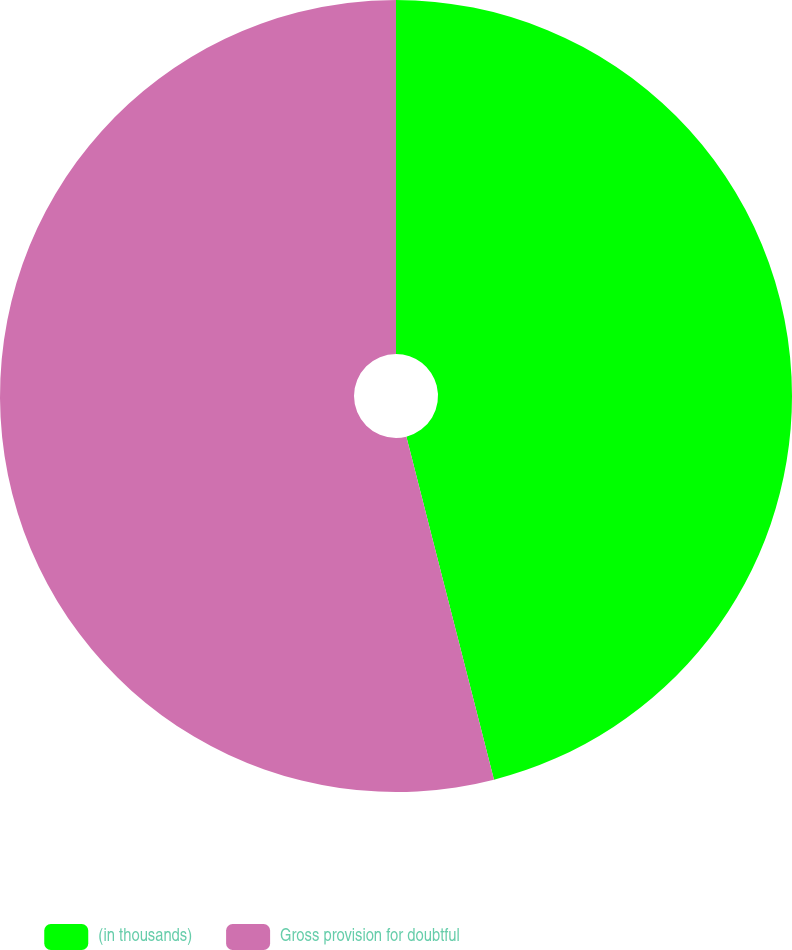Convert chart to OTSL. <chart><loc_0><loc_0><loc_500><loc_500><pie_chart><fcel>(in thousands)<fcel>Gross provision for doubtful<nl><fcel>46.02%<fcel>53.98%<nl></chart> 